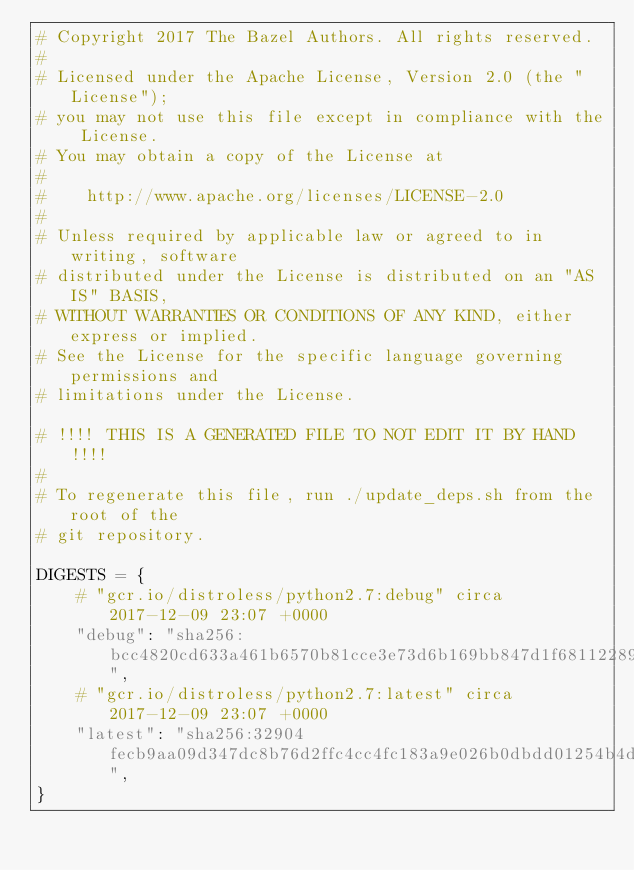Convert code to text. <code><loc_0><loc_0><loc_500><loc_500><_Python_># Copyright 2017 The Bazel Authors. All rights reserved.
#
# Licensed under the Apache License, Version 2.0 (the "License");
# you may not use this file except in compliance with the License.
# You may obtain a copy of the License at
#
#    http://www.apache.org/licenses/LICENSE-2.0
#
# Unless required by applicable law or agreed to in writing, software
# distributed under the License is distributed on an "AS IS" BASIS,
# WITHOUT WARRANTIES OR CONDITIONS OF ANY KIND, either express or implied.
# See the License for the specific language governing permissions and
# limitations under the License.

# !!!! THIS IS A GENERATED FILE TO NOT EDIT IT BY HAND !!!!
#
# To regenerate this file, run ./update_deps.sh from the root of the
# git repository.

DIGESTS = {
    # "gcr.io/distroless/python2.7:debug" circa 2017-12-09 23:07 +0000
    "debug": "sha256:bcc4820cd633a461b6570b81cce3e73d6b169bb847d1f68112289a73da5abf02",
    # "gcr.io/distroless/python2.7:latest" circa 2017-12-09 23:07 +0000
    "latest": "sha256:32904fecb9aa09d347dc8b76d2ffc4cc4fc183a9e026b0dbdd01254b4dfd2d86",
}
</code> 